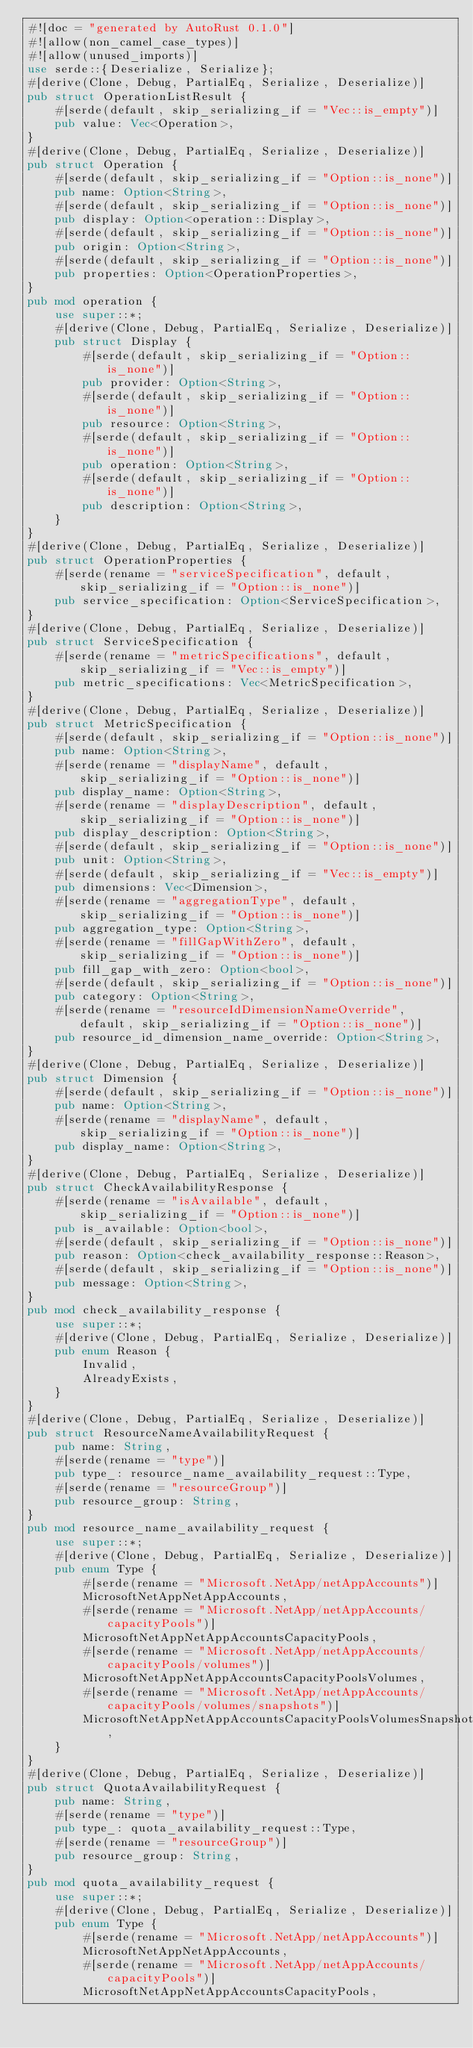Convert code to text. <code><loc_0><loc_0><loc_500><loc_500><_Rust_>#![doc = "generated by AutoRust 0.1.0"]
#![allow(non_camel_case_types)]
#![allow(unused_imports)]
use serde::{Deserialize, Serialize};
#[derive(Clone, Debug, PartialEq, Serialize, Deserialize)]
pub struct OperationListResult {
    #[serde(default, skip_serializing_if = "Vec::is_empty")]
    pub value: Vec<Operation>,
}
#[derive(Clone, Debug, PartialEq, Serialize, Deserialize)]
pub struct Operation {
    #[serde(default, skip_serializing_if = "Option::is_none")]
    pub name: Option<String>,
    #[serde(default, skip_serializing_if = "Option::is_none")]
    pub display: Option<operation::Display>,
    #[serde(default, skip_serializing_if = "Option::is_none")]
    pub origin: Option<String>,
    #[serde(default, skip_serializing_if = "Option::is_none")]
    pub properties: Option<OperationProperties>,
}
pub mod operation {
    use super::*;
    #[derive(Clone, Debug, PartialEq, Serialize, Deserialize)]
    pub struct Display {
        #[serde(default, skip_serializing_if = "Option::is_none")]
        pub provider: Option<String>,
        #[serde(default, skip_serializing_if = "Option::is_none")]
        pub resource: Option<String>,
        #[serde(default, skip_serializing_if = "Option::is_none")]
        pub operation: Option<String>,
        #[serde(default, skip_serializing_if = "Option::is_none")]
        pub description: Option<String>,
    }
}
#[derive(Clone, Debug, PartialEq, Serialize, Deserialize)]
pub struct OperationProperties {
    #[serde(rename = "serviceSpecification", default, skip_serializing_if = "Option::is_none")]
    pub service_specification: Option<ServiceSpecification>,
}
#[derive(Clone, Debug, PartialEq, Serialize, Deserialize)]
pub struct ServiceSpecification {
    #[serde(rename = "metricSpecifications", default, skip_serializing_if = "Vec::is_empty")]
    pub metric_specifications: Vec<MetricSpecification>,
}
#[derive(Clone, Debug, PartialEq, Serialize, Deserialize)]
pub struct MetricSpecification {
    #[serde(default, skip_serializing_if = "Option::is_none")]
    pub name: Option<String>,
    #[serde(rename = "displayName", default, skip_serializing_if = "Option::is_none")]
    pub display_name: Option<String>,
    #[serde(rename = "displayDescription", default, skip_serializing_if = "Option::is_none")]
    pub display_description: Option<String>,
    #[serde(default, skip_serializing_if = "Option::is_none")]
    pub unit: Option<String>,
    #[serde(default, skip_serializing_if = "Vec::is_empty")]
    pub dimensions: Vec<Dimension>,
    #[serde(rename = "aggregationType", default, skip_serializing_if = "Option::is_none")]
    pub aggregation_type: Option<String>,
    #[serde(rename = "fillGapWithZero", default, skip_serializing_if = "Option::is_none")]
    pub fill_gap_with_zero: Option<bool>,
    #[serde(default, skip_serializing_if = "Option::is_none")]
    pub category: Option<String>,
    #[serde(rename = "resourceIdDimensionNameOverride", default, skip_serializing_if = "Option::is_none")]
    pub resource_id_dimension_name_override: Option<String>,
}
#[derive(Clone, Debug, PartialEq, Serialize, Deserialize)]
pub struct Dimension {
    #[serde(default, skip_serializing_if = "Option::is_none")]
    pub name: Option<String>,
    #[serde(rename = "displayName", default, skip_serializing_if = "Option::is_none")]
    pub display_name: Option<String>,
}
#[derive(Clone, Debug, PartialEq, Serialize, Deserialize)]
pub struct CheckAvailabilityResponse {
    #[serde(rename = "isAvailable", default, skip_serializing_if = "Option::is_none")]
    pub is_available: Option<bool>,
    #[serde(default, skip_serializing_if = "Option::is_none")]
    pub reason: Option<check_availability_response::Reason>,
    #[serde(default, skip_serializing_if = "Option::is_none")]
    pub message: Option<String>,
}
pub mod check_availability_response {
    use super::*;
    #[derive(Clone, Debug, PartialEq, Serialize, Deserialize)]
    pub enum Reason {
        Invalid,
        AlreadyExists,
    }
}
#[derive(Clone, Debug, PartialEq, Serialize, Deserialize)]
pub struct ResourceNameAvailabilityRequest {
    pub name: String,
    #[serde(rename = "type")]
    pub type_: resource_name_availability_request::Type,
    #[serde(rename = "resourceGroup")]
    pub resource_group: String,
}
pub mod resource_name_availability_request {
    use super::*;
    #[derive(Clone, Debug, PartialEq, Serialize, Deserialize)]
    pub enum Type {
        #[serde(rename = "Microsoft.NetApp/netAppAccounts")]
        MicrosoftNetAppNetAppAccounts,
        #[serde(rename = "Microsoft.NetApp/netAppAccounts/capacityPools")]
        MicrosoftNetAppNetAppAccountsCapacityPools,
        #[serde(rename = "Microsoft.NetApp/netAppAccounts/capacityPools/volumes")]
        MicrosoftNetAppNetAppAccountsCapacityPoolsVolumes,
        #[serde(rename = "Microsoft.NetApp/netAppAccounts/capacityPools/volumes/snapshots")]
        MicrosoftNetAppNetAppAccountsCapacityPoolsVolumesSnapshots,
    }
}
#[derive(Clone, Debug, PartialEq, Serialize, Deserialize)]
pub struct QuotaAvailabilityRequest {
    pub name: String,
    #[serde(rename = "type")]
    pub type_: quota_availability_request::Type,
    #[serde(rename = "resourceGroup")]
    pub resource_group: String,
}
pub mod quota_availability_request {
    use super::*;
    #[derive(Clone, Debug, PartialEq, Serialize, Deserialize)]
    pub enum Type {
        #[serde(rename = "Microsoft.NetApp/netAppAccounts")]
        MicrosoftNetAppNetAppAccounts,
        #[serde(rename = "Microsoft.NetApp/netAppAccounts/capacityPools")]
        MicrosoftNetAppNetAppAccountsCapacityPools,</code> 